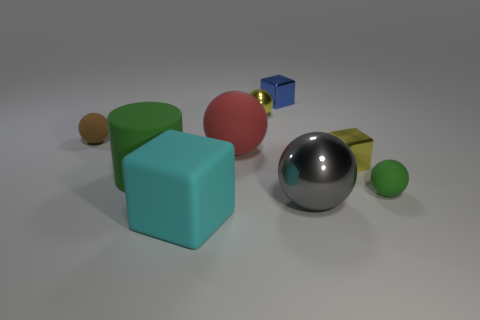Subtract all yellow balls. How many balls are left? 4 Subtract all tiny brown rubber spheres. How many spheres are left? 4 Add 1 small blue rubber cylinders. How many objects exist? 10 Subtract all brown balls. Subtract all green cylinders. How many balls are left? 4 Subtract all balls. How many objects are left? 4 Add 9 yellow blocks. How many yellow blocks are left? 10 Add 8 small green matte spheres. How many small green matte spheres exist? 9 Subtract 0 blue spheres. How many objects are left? 9 Subtract all tiny blue cubes. Subtract all big shiny objects. How many objects are left? 7 